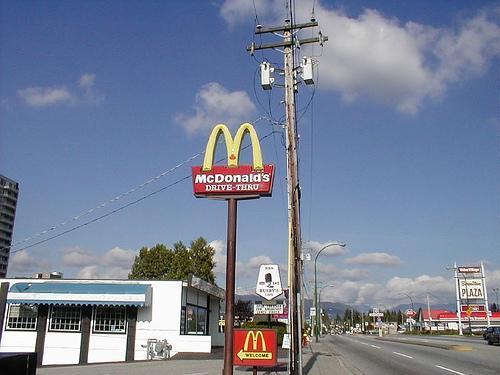How many people have on a salomon shirt?
Give a very brief answer. 0. 